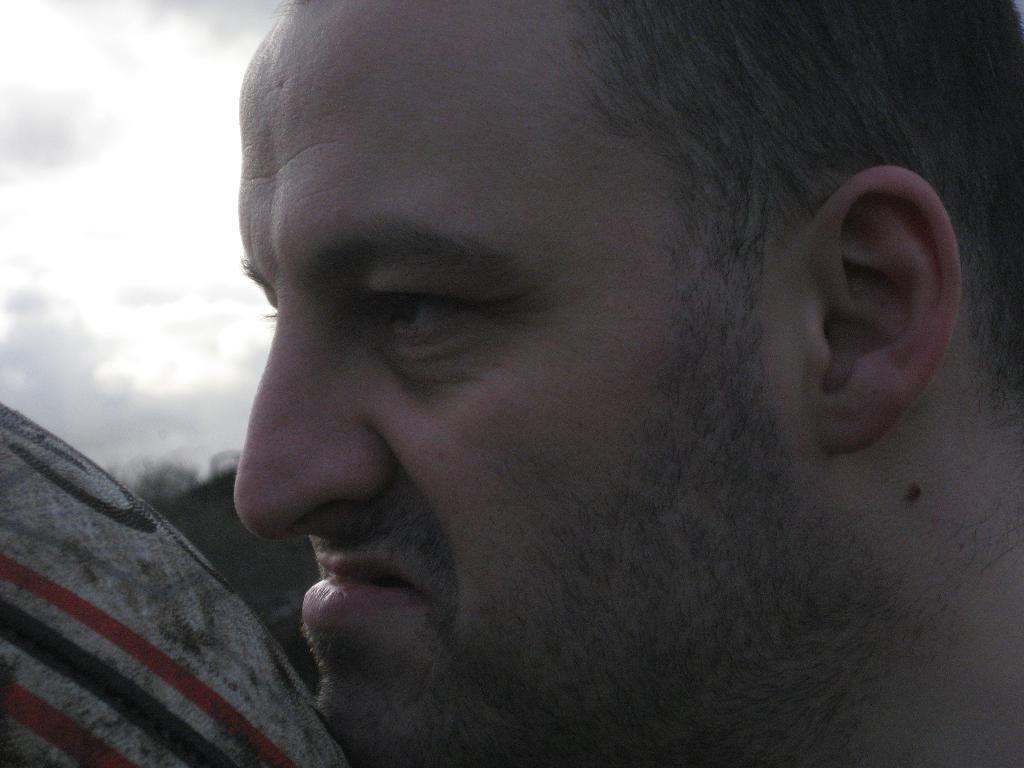What is located on the right side of the image? There is a person's head on the right side of the image. What can be seen on the left side of the image? There are trees and a ball on the left side of the image. What is visible in the top left corner of the image? There are clouds visible in the top left corner of the image. What type of cream is being used to cover the dirt in the image? There is no cream or dirt present in the image; it features a person's head, trees, a ball, and clouds. How many bags of popcorn can be seen in the image? There are no bags of popcorn present in the image. 